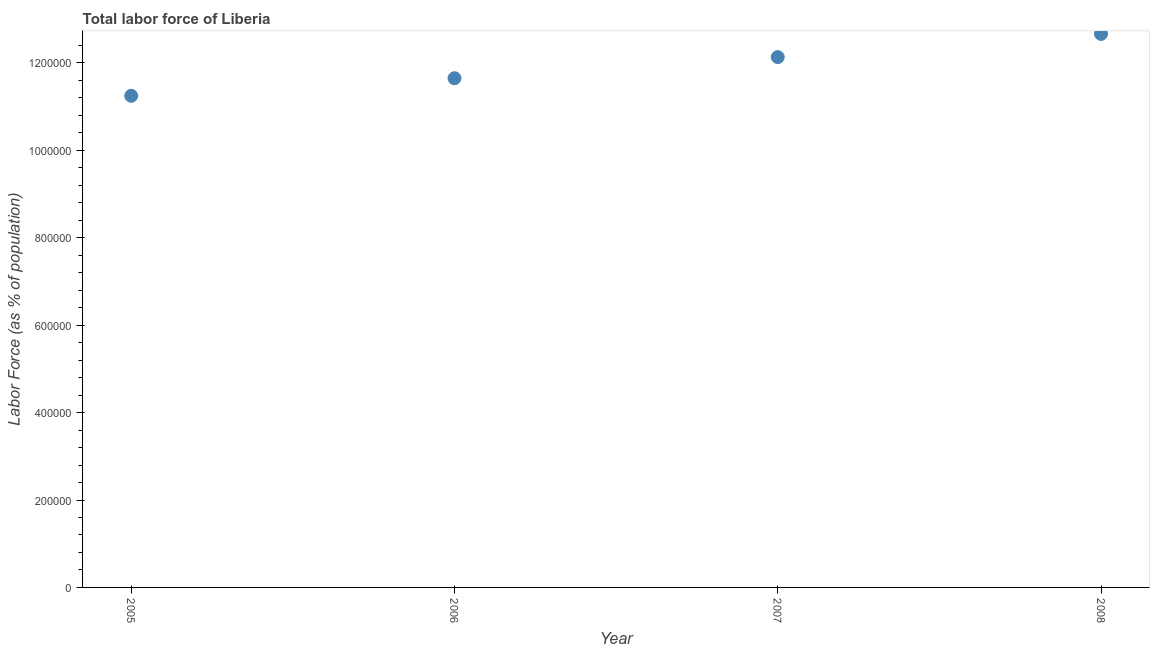What is the total labor force in 2008?
Make the answer very short. 1.27e+06. Across all years, what is the maximum total labor force?
Make the answer very short. 1.27e+06. Across all years, what is the minimum total labor force?
Keep it short and to the point. 1.12e+06. In which year was the total labor force maximum?
Ensure brevity in your answer.  2008. What is the sum of the total labor force?
Provide a short and direct response. 4.77e+06. What is the difference between the total labor force in 2006 and 2007?
Provide a short and direct response. -4.83e+04. What is the average total labor force per year?
Your answer should be very brief. 1.19e+06. What is the median total labor force?
Give a very brief answer. 1.19e+06. In how many years, is the total labor force greater than 40000 %?
Offer a very short reply. 4. What is the ratio of the total labor force in 2005 to that in 2008?
Keep it short and to the point. 0.89. Is the total labor force in 2007 less than that in 2008?
Ensure brevity in your answer.  Yes. Is the difference between the total labor force in 2005 and 2007 greater than the difference between any two years?
Offer a very short reply. No. What is the difference between the highest and the second highest total labor force?
Ensure brevity in your answer.  5.31e+04. What is the difference between the highest and the lowest total labor force?
Provide a short and direct response. 1.42e+05. Does the total labor force monotonically increase over the years?
Make the answer very short. Yes. How many dotlines are there?
Offer a very short reply. 1. How many years are there in the graph?
Your response must be concise. 4. What is the difference between two consecutive major ticks on the Y-axis?
Provide a short and direct response. 2.00e+05. Does the graph contain any zero values?
Provide a short and direct response. No. Does the graph contain grids?
Provide a short and direct response. No. What is the title of the graph?
Your answer should be very brief. Total labor force of Liberia. What is the label or title of the Y-axis?
Give a very brief answer. Labor Force (as % of population). What is the Labor Force (as % of population) in 2005?
Provide a succinct answer. 1.12e+06. What is the Labor Force (as % of population) in 2006?
Provide a short and direct response. 1.17e+06. What is the Labor Force (as % of population) in 2007?
Keep it short and to the point. 1.21e+06. What is the Labor Force (as % of population) in 2008?
Give a very brief answer. 1.27e+06. What is the difference between the Labor Force (as % of population) in 2005 and 2006?
Ensure brevity in your answer.  -4.02e+04. What is the difference between the Labor Force (as % of population) in 2005 and 2007?
Provide a short and direct response. -8.85e+04. What is the difference between the Labor Force (as % of population) in 2005 and 2008?
Your answer should be very brief. -1.42e+05. What is the difference between the Labor Force (as % of population) in 2006 and 2007?
Your answer should be compact. -4.83e+04. What is the difference between the Labor Force (as % of population) in 2006 and 2008?
Your answer should be compact. -1.01e+05. What is the difference between the Labor Force (as % of population) in 2007 and 2008?
Offer a very short reply. -5.31e+04. What is the ratio of the Labor Force (as % of population) in 2005 to that in 2006?
Offer a very short reply. 0.97. What is the ratio of the Labor Force (as % of population) in 2005 to that in 2007?
Ensure brevity in your answer.  0.93. What is the ratio of the Labor Force (as % of population) in 2005 to that in 2008?
Ensure brevity in your answer.  0.89. What is the ratio of the Labor Force (as % of population) in 2007 to that in 2008?
Offer a terse response. 0.96. 